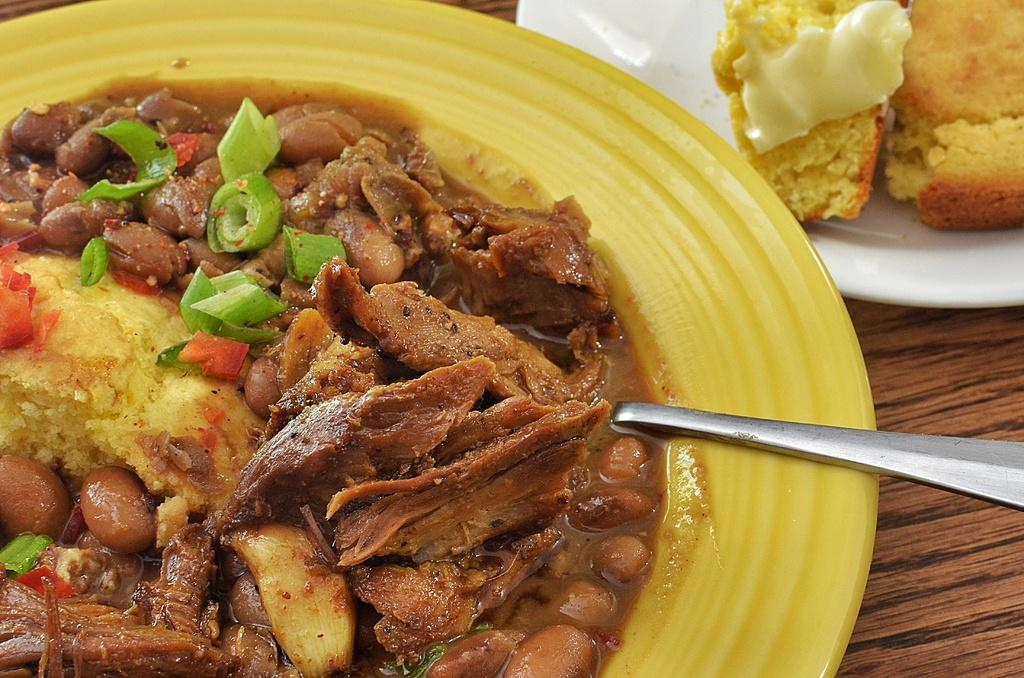What is on the plates that are visible in the image? There are plates containing food in the image. What utensil can be seen on the right side of the image? There is a spoon on the right side of the image. Is there a volcano erupting in the background of the image? No, there is no volcano or any indication of an eruption in the image. 